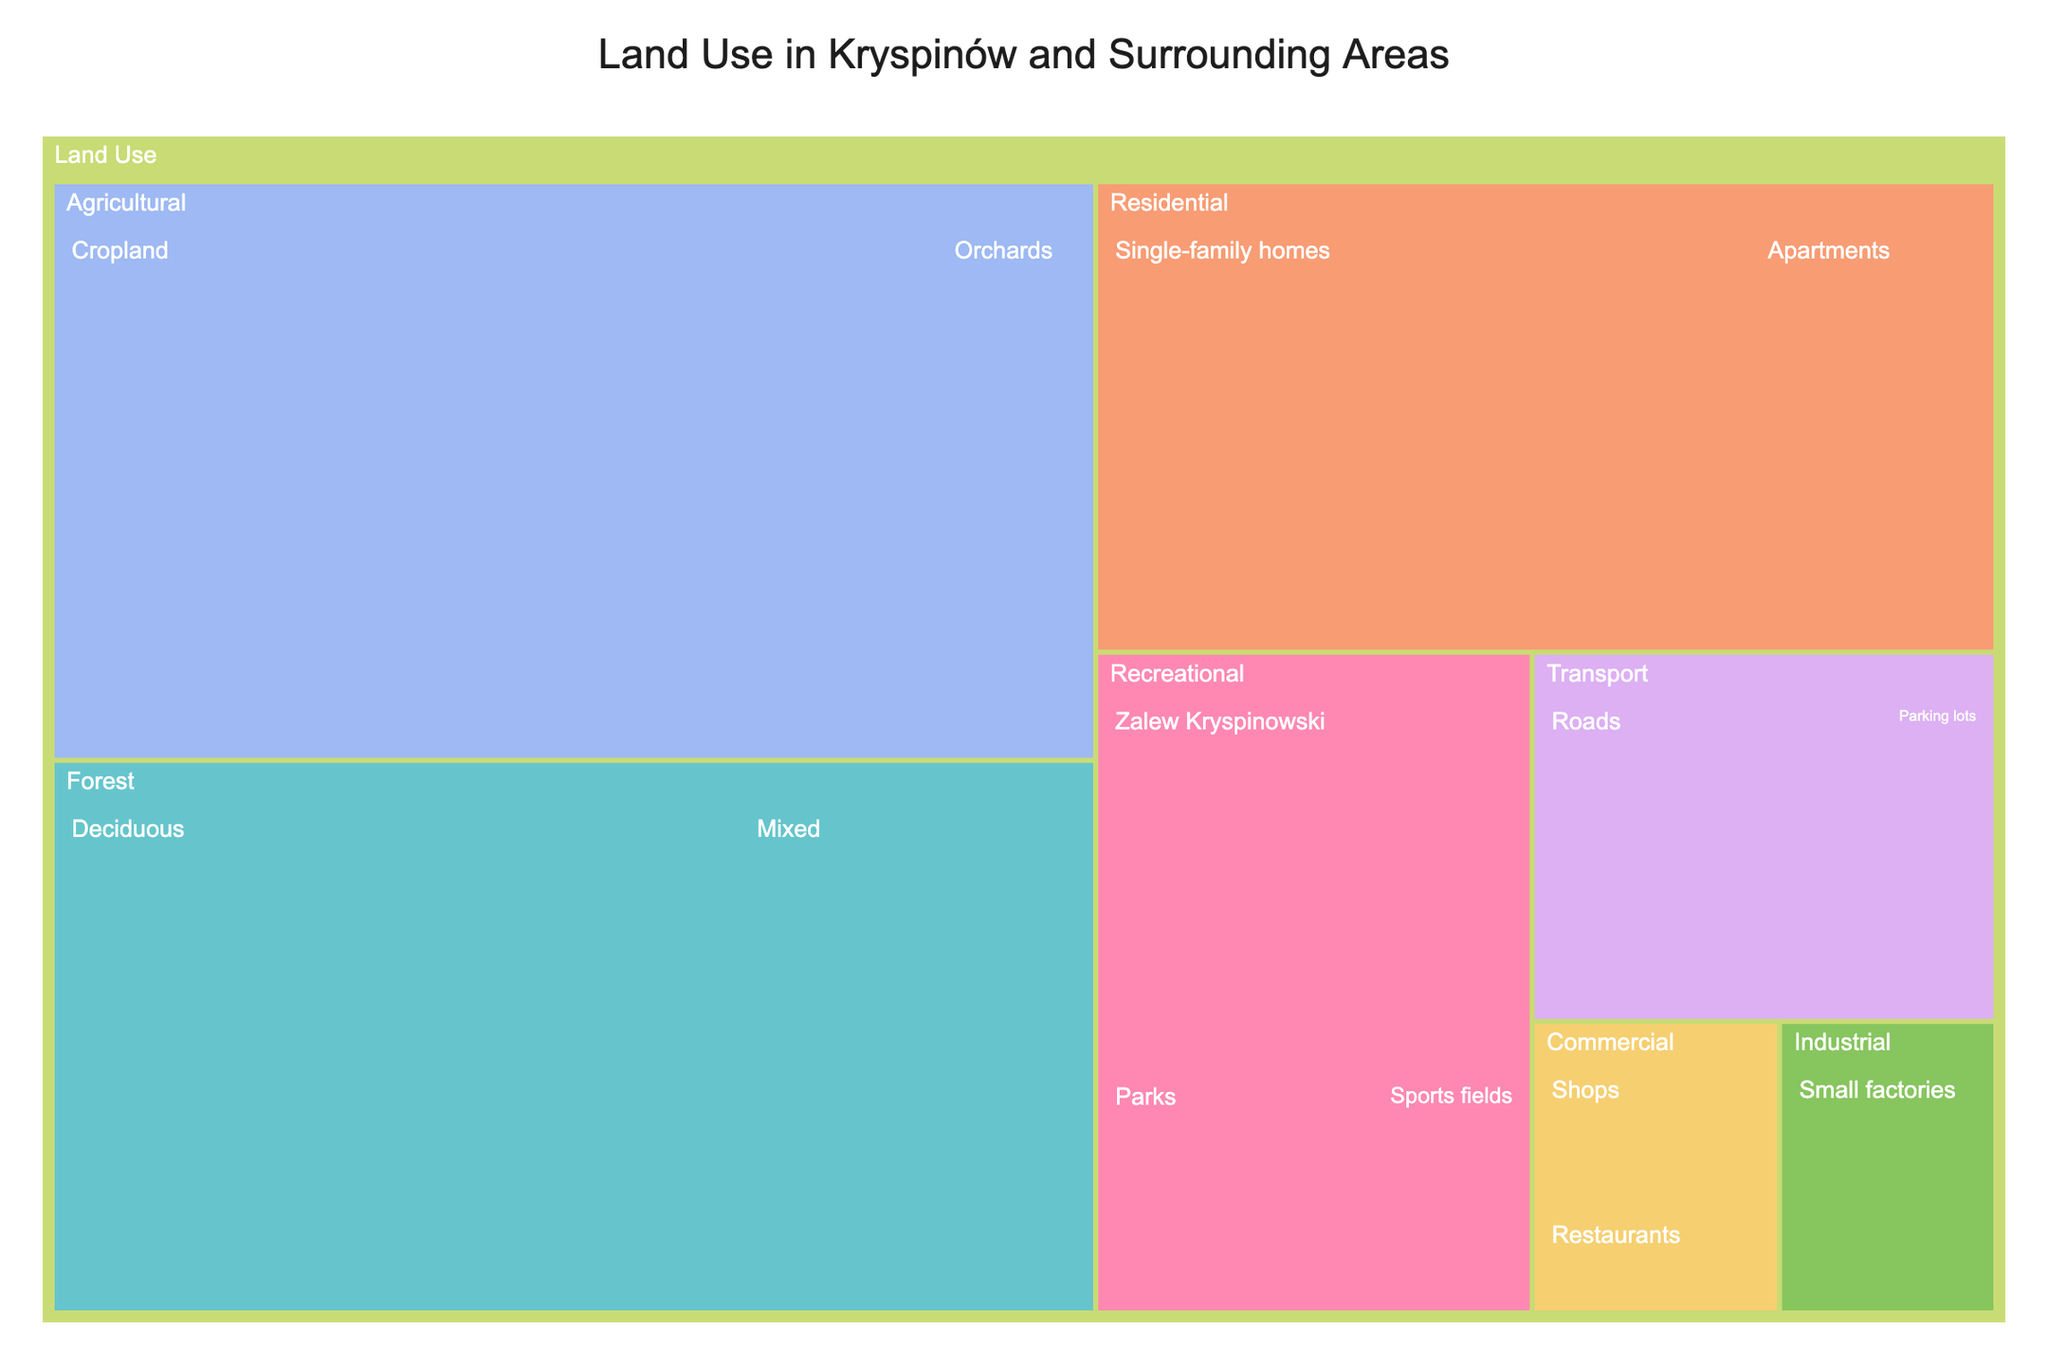what is the title of the treemap? The title is usually found at the top of the treemap, providing an overview of what the visualization represents.
Answer: Land Use in Kryspinów and Surrounding Areas How much area is dedicated to residential use? To find the area dedicated to residential use, sum the areas of "Single-family homes" and "Apartments". 350 ha + 120 ha = 470 ha.
Answer: 470 ha Which type of land use represents the largest area in the figure? Look for the largest section in the treemap, which is "Cropland" under the "Agricultural" category.
Answer: Agricultural (Cropland) What is the combined area of forested land? Sum the areas of "Deciduous" and "Mixed" forests. 430 ha + 210 ha = 640 ha.
Answer: 640 ha Is there more area dedicated to residential or recreational use? Compare the summed areas of "Single-family homes" and "Apartments" (470 ha) with the sum of "Zalew Kryspinowski", "Parks", and "Sports fields" (200 ha + 80 ha + 40 ha = 320 ha). Residential (470 ha) is greater than Recreational (320 ha).
Answer: Residential Which subcategory within transportation has a smaller area covered? Compare the area covered by "Roads" (150 ha) with "Parking lots" (40 ha).
Answer: Parking lots What is the total area for commercial land use? Sum the areas of "Shops" and "Restaurants". 50 ha + 30 ha = 80 ha.
Answer: 80 ha How does the area of small factories compare to the area of parks? Compare the area of "Small factories" (70 ha) with the area of "Parks" (80 ha). "Parks" has a larger area.
Answer: Parks What is the total area represented in the treemap? Sum the areas of all subcategories: 350 + 120 + 580 + 90 + 200 + 80 + 40 + 430 + 210 + 50 + 30 + 70 + 150 + 40 = 2440 ha.
Answer: 2440 ha What percentage of the total land use is allocated to cropland? Divide the area of cropland (580 ha) by the total area (2440 ha) and multiply by 100. (580 / 2440) * 100 ≈ 23.77%.
Answer: ~23.77% 